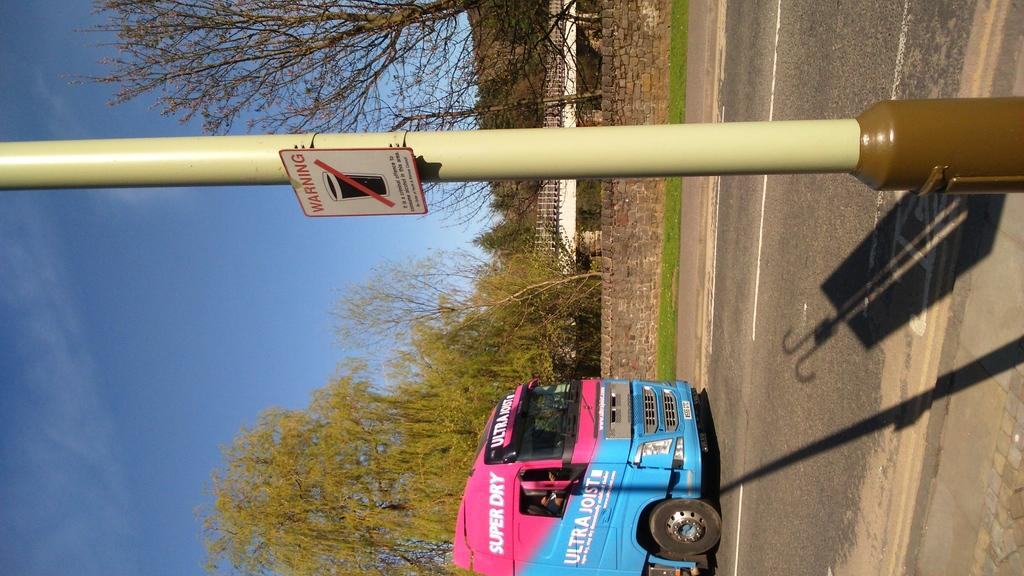<image>
Give a short and clear explanation of the subsequent image. A pink and blue truck with the words Super Dry sits near a Warning sign 